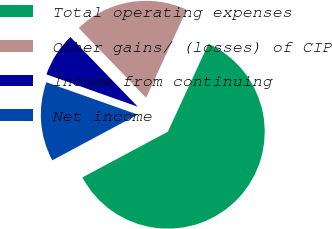Convert chart to OTSL. <chart><loc_0><loc_0><loc_500><loc_500><pie_chart><fcel>Total operating expenses<fcel>Other gains/ (losses) of CIP<fcel>Income from continuing<fcel>Net income<nl><fcel>60.3%<fcel>19.12%<fcel>7.35%<fcel>13.23%<nl></chart> 